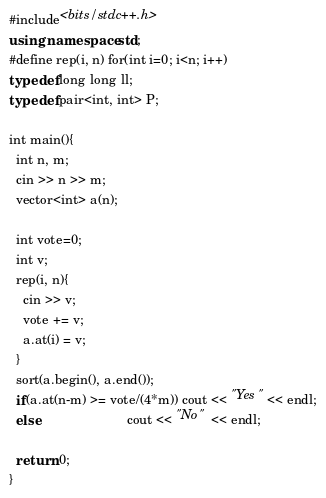Convert code to text. <code><loc_0><loc_0><loc_500><loc_500><_C++_>#include<bits/stdc++.h>
using namespace std;
#define rep(i, n) for(int i=0; i<n; i++)
typedef long long ll;
typedef pair<int, int> P;
 
int main(){
  int n, m;
  cin >> n >> m;
  vector<int> a(n);
  
  int vote=0;
  int v;
  rep(i, n){
    cin >> v;
    vote += v;
    a.at(i) = v;
  }
  sort(a.begin(), a.end());
  if(a.at(n-m) >= vote/(4*m)) cout << "Yes" << endl;
  else                        cout << "No"  << endl;
  
  return 0;
}

</code> 